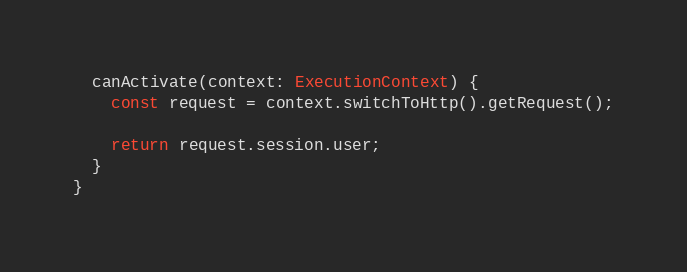<code> <loc_0><loc_0><loc_500><loc_500><_TypeScript_>  canActivate(context: ExecutionContext) {
    const request = context.switchToHttp().getRequest();

    return request.session.user;
  }
}
</code> 